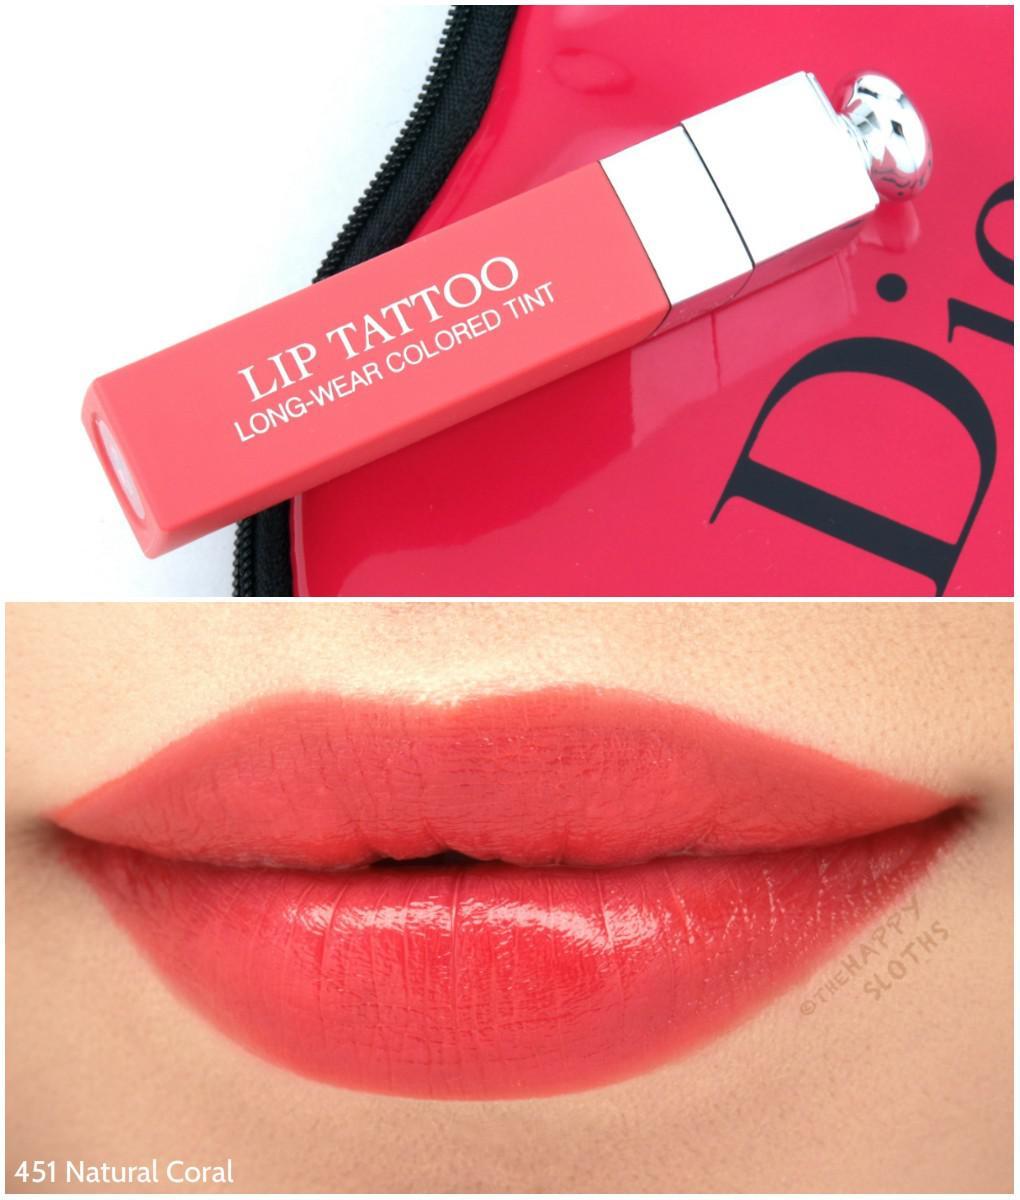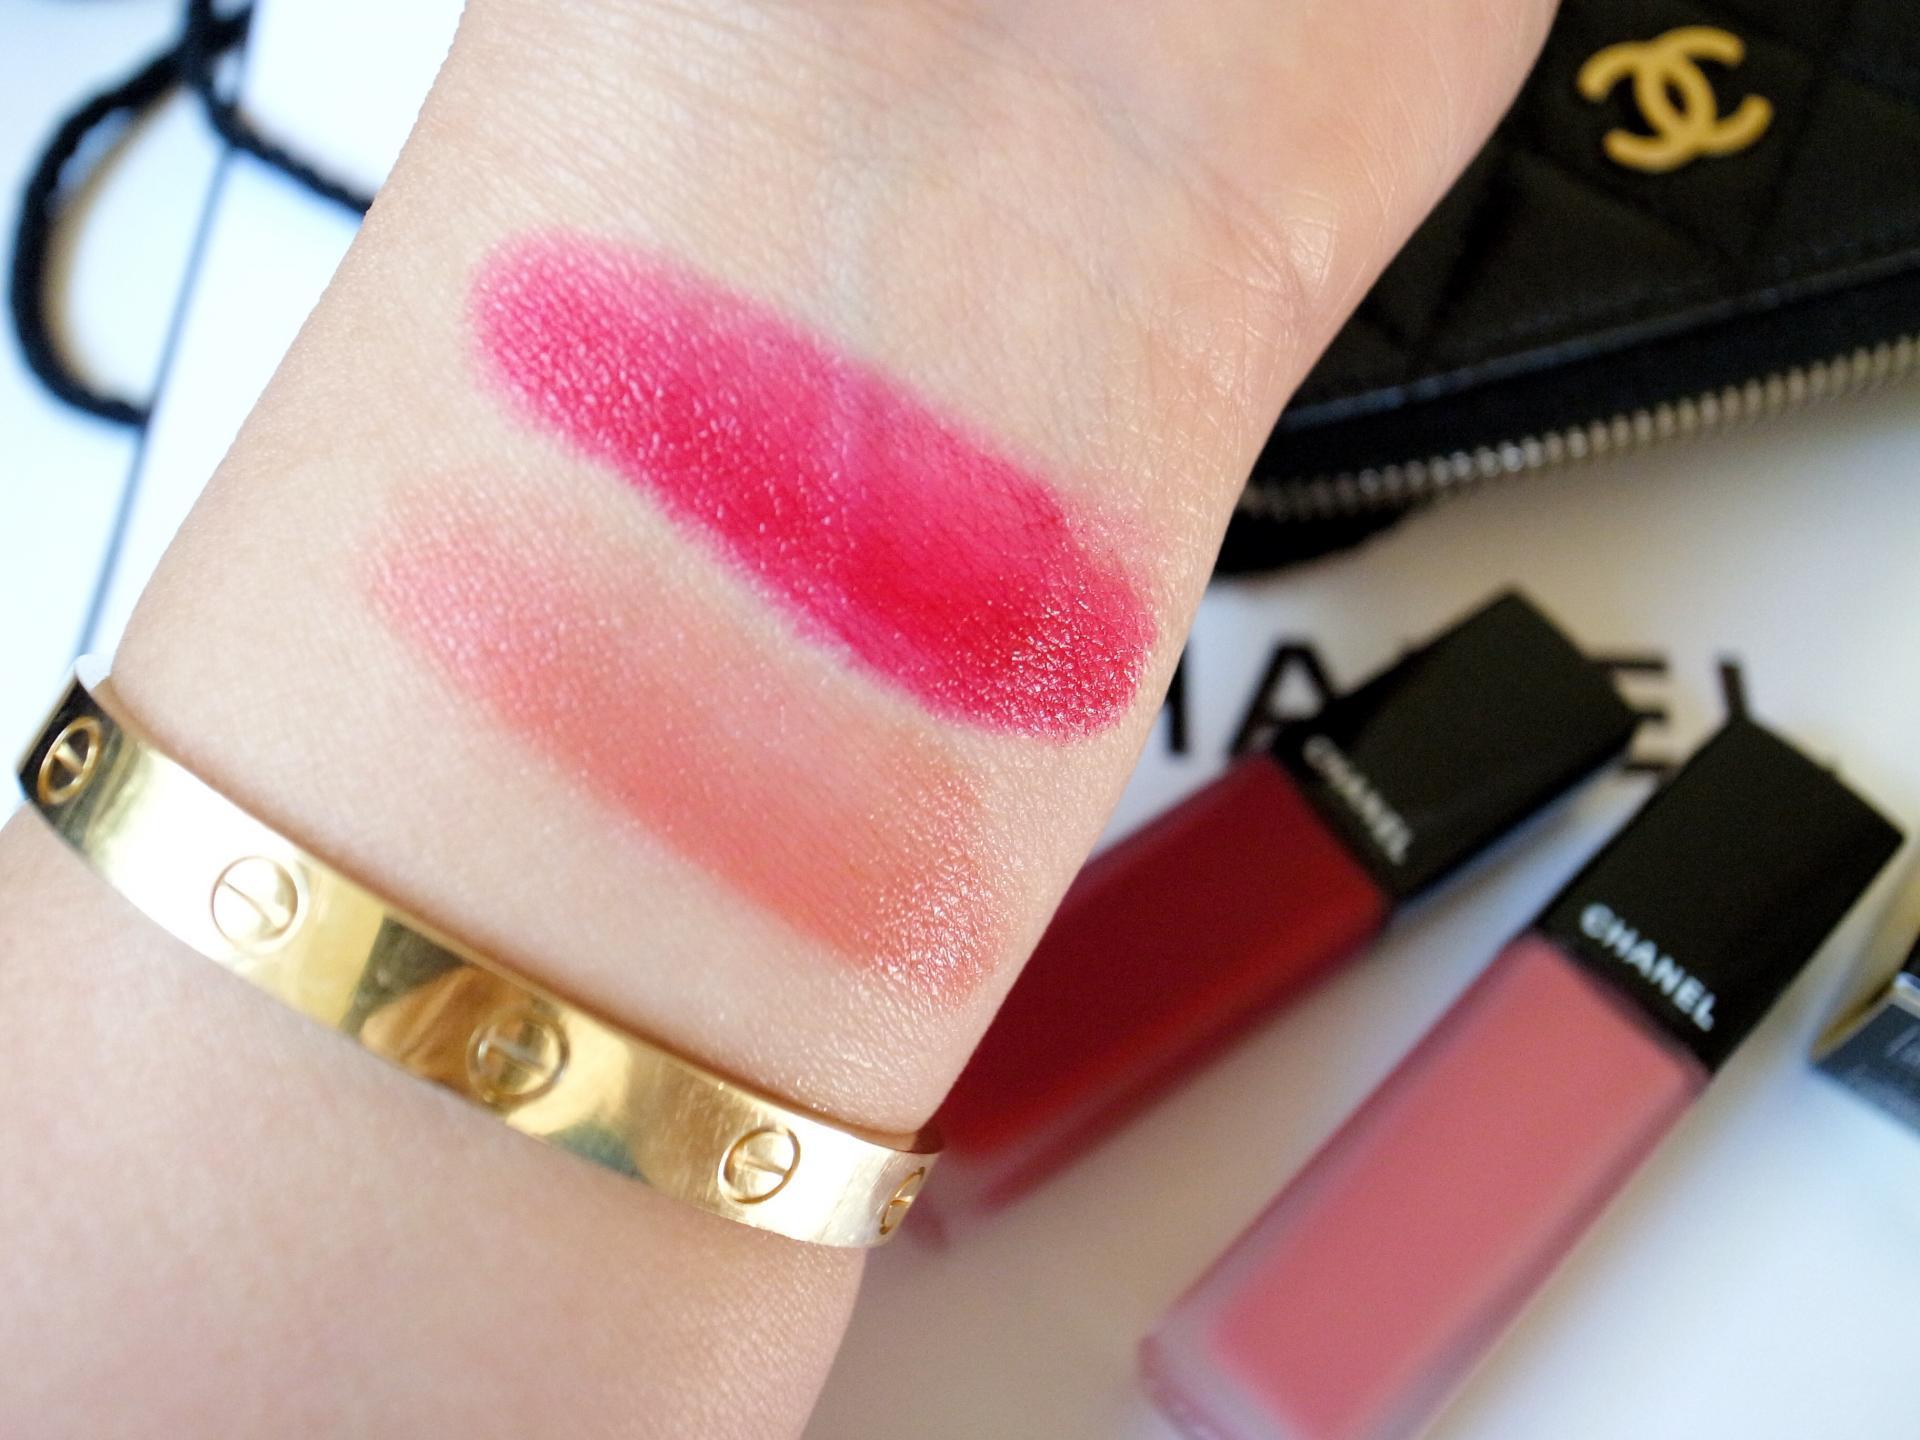The first image is the image on the left, the second image is the image on the right. Assess this claim about the two images: "The left image shows a lipstick color test on a person's wrist area.". Correct or not? Answer yes or no. No. 